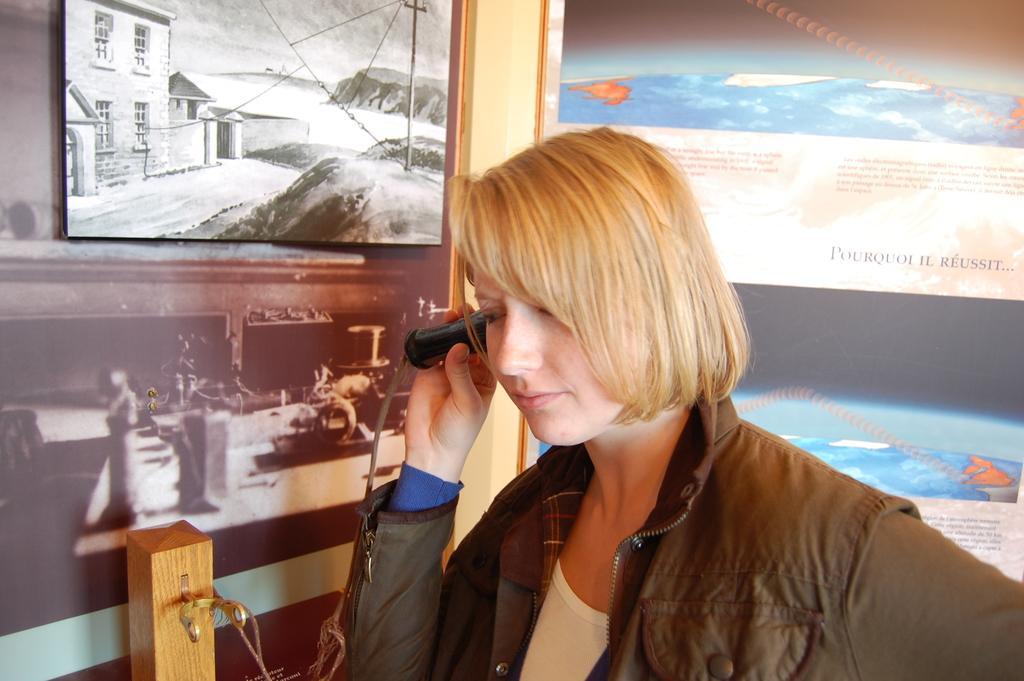Can you describe this image briefly? In the image we can see a woman wearing clothes, the woman is holding an object in her hand. This is a frame and a poster, this is an object. 